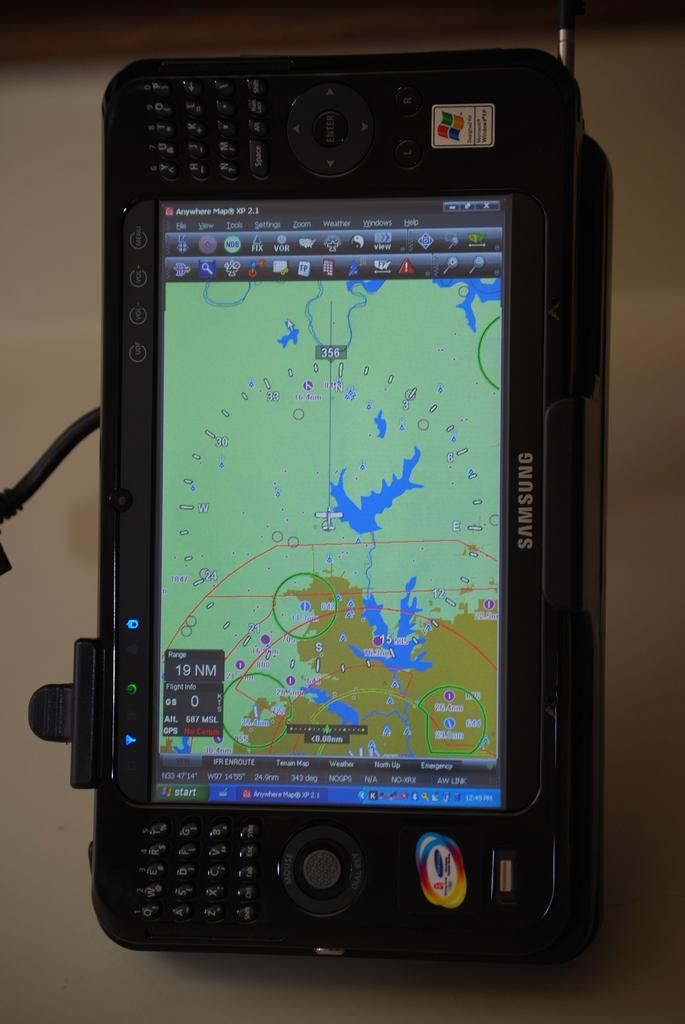Provide a one-sentence caption for the provided image. A Samsung electronic device shows a map and coordinates on screen. 